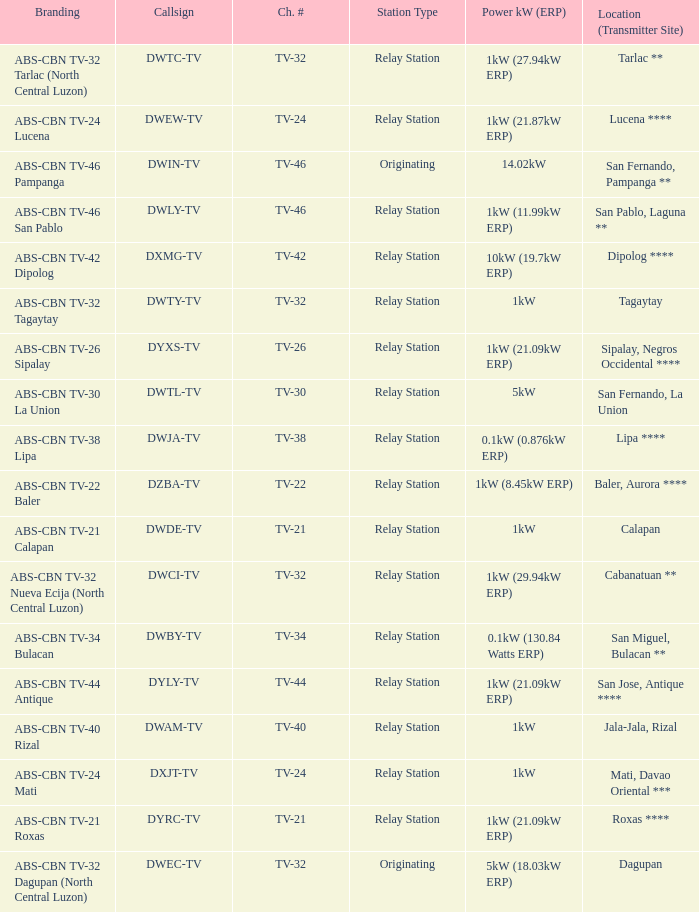Would you be able to parse every entry in this table? {'header': ['Branding', 'Callsign', 'Ch. #', 'Station Type', 'Power kW (ERP)', 'Location (Transmitter Site)'], 'rows': [['ABS-CBN TV-32 Tarlac (North Central Luzon)', 'DWTC-TV', 'TV-32', 'Relay Station', '1kW (27.94kW ERP)', 'Tarlac **'], ['ABS-CBN TV-24 Lucena', 'DWEW-TV', 'TV-24', 'Relay Station', '1kW (21.87kW ERP)', 'Lucena ****'], ['ABS-CBN TV-46 Pampanga', 'DWIN-TV', 'TV-46', 'Originating', '14.02kW', 'San Fernando, Pampanga **'], ['ABS-CBN TV-46 San Pablo', 'DWLY-TV', 'TV-46', 'Relay Station', '1kW (11.99kW ERP)', 'San Pablo, Laguna **'], ['ABS-CBN TV-42 Dipolog', 'DXMG-TV', 'TV-42', 'Relay Station', '10kW (19.7kW ERP)', 'Dipolog ****'], ['ABS-CBN TV-32 Tagaytay', 'DWTY-TV', 'TV-32', 'Relay Station', '1kW', 'Tagaytay'], ['ABS-CBN TV-26 Sipalay', 'DYXS-TV', 'TV-26', 'Relay Station', '1kW (21.09kW ERP)', 'Sipalay, Negros Occidental ****'], ['ABS-CBN TV-30 La Union', 'DWTL-TV', 'TV-30', 'Relay Station', '5kW', 'San Fernando, La Union'], ['ABS-CBN TV-38 Lipa', 'DWJA-TV', 'TV-38', 'Relay Station', '0.1kW (0.876kW ERP)', 'Lipa ****'], ['ABS-CBN TV-22 Baler', 'DZBA-TV', 'TV-22', 'Relay Station', '1kW (8.45kW ERP)', 'Baler, Aurora ****'], ['ABS-CBN TV-21 Calapan', 'DWDE-TV', 'TV-21', 'Relay Station', '1kW', 'Calapan'], ['ABS-CBN TV-32 Nueva Ecija (North Central Luzon)', 'DWCI-TV', 'TV-32', 'Relay Station', '1kW (29.94kW ERP)', 'Cabanatuan **'], ['ABS-CBN TV-34 Bulacan', 'DWBY-TV', 'TV-34', 'Relay Station', '0.1kW (130.84 Watts ERP)', 'San Miguel, Bulacan **'], ['ABS-CBN TV-44 Antique', 'DYLY-TV', 'TV-44', 'Relay Station', '1kW (21.09kW ERP)', 'San Jose, Antique ****'], ['ABS-CBN TV-40 Rizal', 'DWAM-TV', 'TV-40', 'Relay Station', '1kW', 'Jala-Jala, Rizal'], ['ABS-CBN TV-24 Mati', 'DXJT-TV', 'TV-24', 'Relay Station', '1kW', 'Mati, Davao Oriental ***'], ['ABS-CBN TV-21 Roxas', 'DYRC-TV', 'TV-21', 'Relay Station', '1kW (21.09kW ERP)', 'Roxas ****'], ['ABS-CBN TV-32 Dagupan (North Central Luzon)', 'DWEC-TV', 'TV-32', 'Originating', '5kW (18.03kW ERP)', 'Dagupan']]} The location (transmitter site) San Fernando, Pampanga ** has what Power kW (ERP)? 14.02kW. 